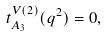<formula> <loc_0><loc_0><loc_500><loc_500>t _ { A _ { 3 } } ^ { V ( 2 ) } ( q ^ { 2 } ) = 0 ,</formula> 